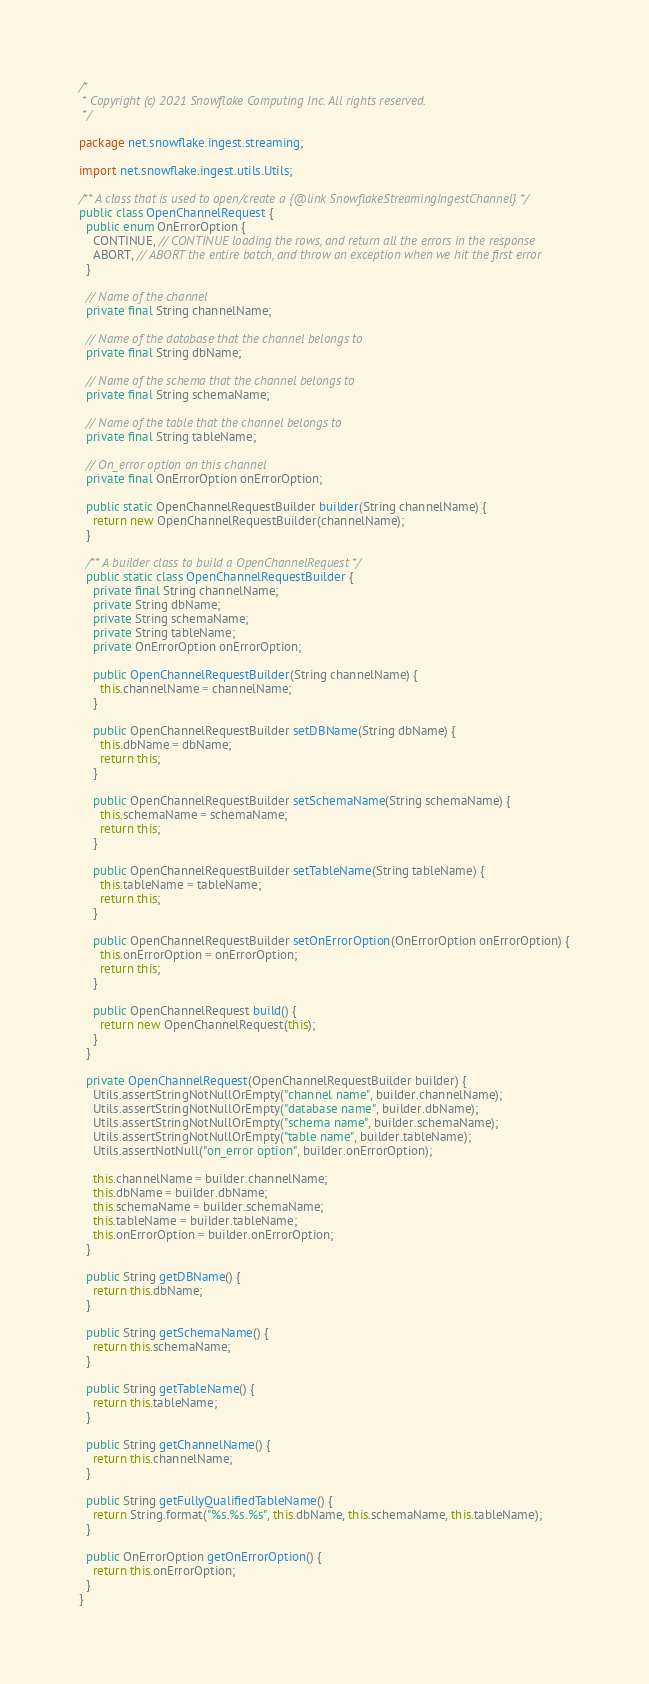<code> <loc_0><loc_0><loc_500><loc_500><_Java_>/*
 * Copyright (c) 2021 Snowflake Computing Inc. All rights reserved.
 */

package net.snowflake.ingest.streaming;

import net.snowflake.ingest.utils.Utils;

/** A class that is used to open/create a {@link SnowflakeStreamingIngestChannel} */
public class OpenChannelRequest {
  public enum OnErrorOption {
    CONTINUE, // CONTINUE loading the rows, and return all the errors in the response
    ABORT, // ABORT the entire batch, and throw an exception when we hit the first error
  }

  // Name of the channel
  private final String channelName;

  // Name of the database that the channel belongs to
  private final String dbName;

  // Name of the schema that the channel belongs to
  private final String schemaName;

  // Name of the table that the channel belongs to
  private final String tableName;

  // On_error option on this channel
  private final OnErrorOption onErrorOption;

  public static OpenChannelRequestBuilder builder(String channelName) {
    return new OpenChannelRequestBuilder(channelName);
  }

  /** A builder class to build a OpenChannelRequest */
  public static class OpenChannelRequestBuilder {
    private final String channelName;
    private String dbName;
    private String schemaName;
    private String tableName;
    private OnErrorOption onErrorOption;

    public OpenChannelRequestBuilder(String channelName) {
      this.channelName = channelName;
    }

    public OpenChannelRequestBuilder setDBName(String dbName) {
      this.dbName = dbName;
      return this;
    }

    public OpenChannelRequestBuilder setSchemaName(String schemaName) {
      this.schemaName = schemaName;
      return this;
    }

    public OpenChannelRequestBuilder setTableName(String tableName) {
      this.tableName = tableName;
      return this;
    }

    public OpenChannelRequestBuilder setOnErrorOption(OnErrorOption onErrorOption) {
      this.onErrorOption = onErrorOption;
      return this;
    }

    public OpenChannelRequest build() {
      return new OpenChannelRequest(this);
    }
  }

  private OpenChannelRequest(OpenChannelRequestBuilder builder) {
    Utils.assertStringNotNullOrEmpty("channel name", builder.channelName);
    Utils.assertStringNotNullOrEmpty("database name", builder.dbName);
    Utils.assertStringNotNullOrEmpty("schema name", builder.schemaName);
    Utils.assertStringNotNullOrEmpty("table name", builder.tableName);
    Utils.assertNotNull("on_error option", builder.onErrorOption);

    this.channelName = builder.channelName;
    this.dbName = builder.dbName;
    this.schemaName = builder.schemaName;
    this.tableName = builder.tableName;
    this.onErrorOption = builder.onErrorOption;
  }

  public String getDBName() {
    return this.dbName;
  }

  public String getSchemaName() {
    return this.schemaName;
  }

  public String getTableName() {
    return this.tableName;
  }

  public String getChannelName() {
    return this.channelName;
  }

  public String getFullyQualifiedTableName() {
    return String.format("%s.%s.%s", this.dbName, this.schemaName, this.tableName);
  }

  public OnErrorOption getOnErrorOption() {
    return this.onErrorOption;
  }
}
</code> 